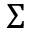Convert formula to latex. <formula><loc_0><loc_0><loc_500><loc_500>\Sigma</formula> 